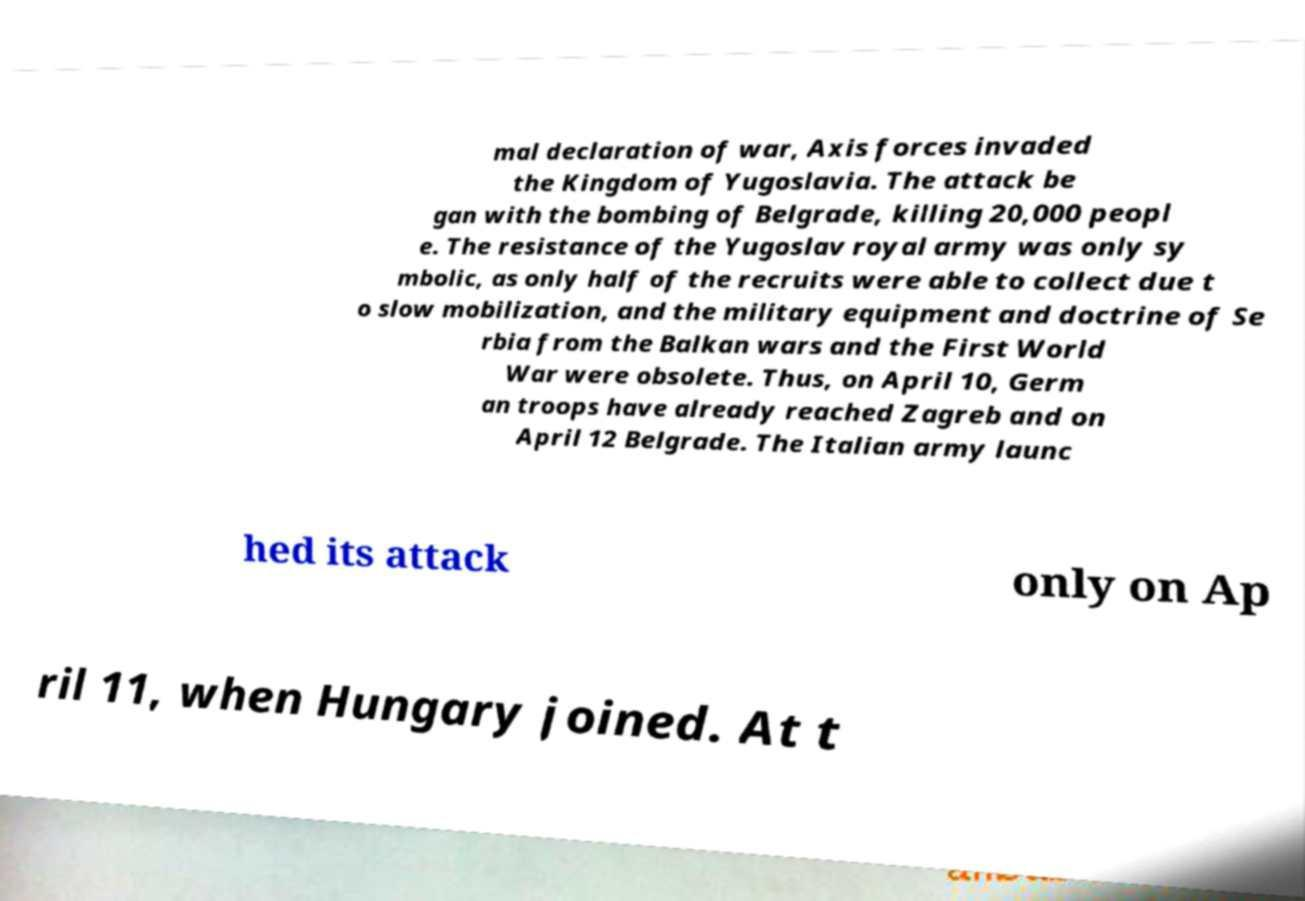What messages or text are displayed in this image? I need them in a readable, typed format. mal declaration of war, Axis forces invaded the Kingdom of Yugoslavia. The attack be gan with the bombing of Belgrade, killing 20,000 peopl e. The resistance of the Yugoslav royal army was only sy mbolic, as only half of the recruits were able to collect due t o slow mobilization, and the military equipment and doctrine of Se rbia from the Balkan wars and the First World War were obsolete. Thus, on April 10, Germ an troops have already reached Zagreb and on April 12 Belgrade. The Italian army launc hed its attack only on Ap ril 11, when Hungary joined. At t 